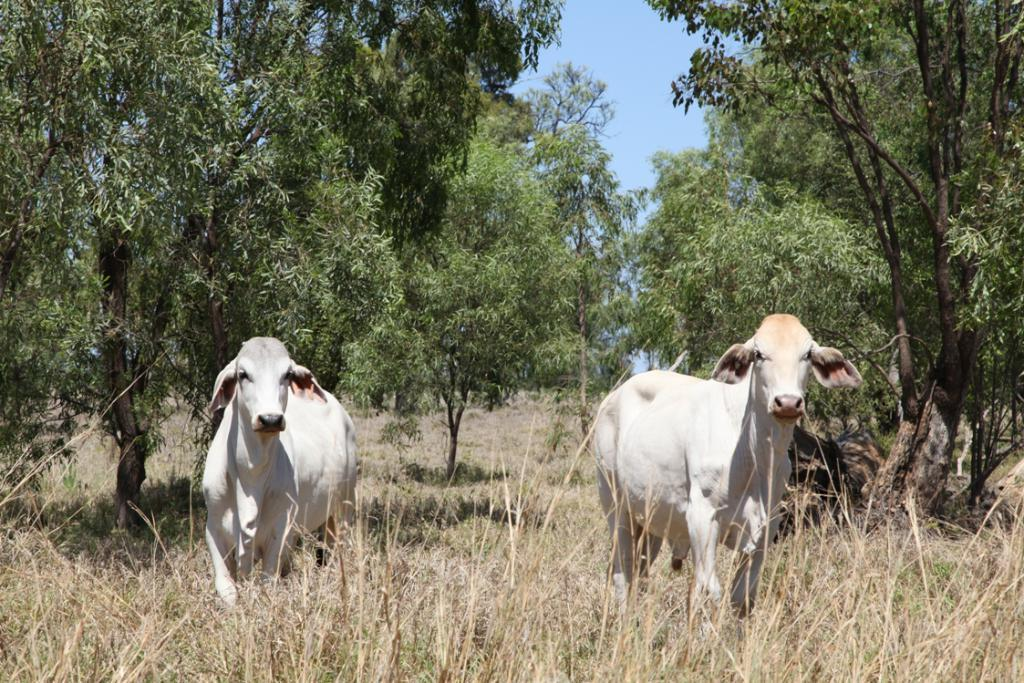What type of ground is visible in the image? There is grass ground in the image. What animals are standing on the grass ground? Two white-colored cows are standing on the grass ground. What can be seen in the background of the image? There are trees and the sky visible in the background of the image. What type of war is being fought in the image? There is no war or any indication of conflict in the image; it features two white-colored cows standing on grass ground with trees and the sky visible in the background. 